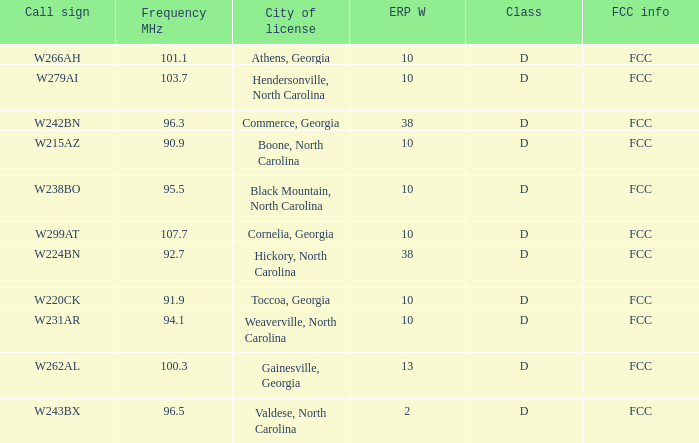What city has larger than 94.1 as a frequency? Athens, Georgia, Commerce, Georgia, Cornelia, Georgia, Gainesville, Georgia, Black Mountain, North Carolina, Hendersonville, North Carolina, Valdese, North Carolina. 